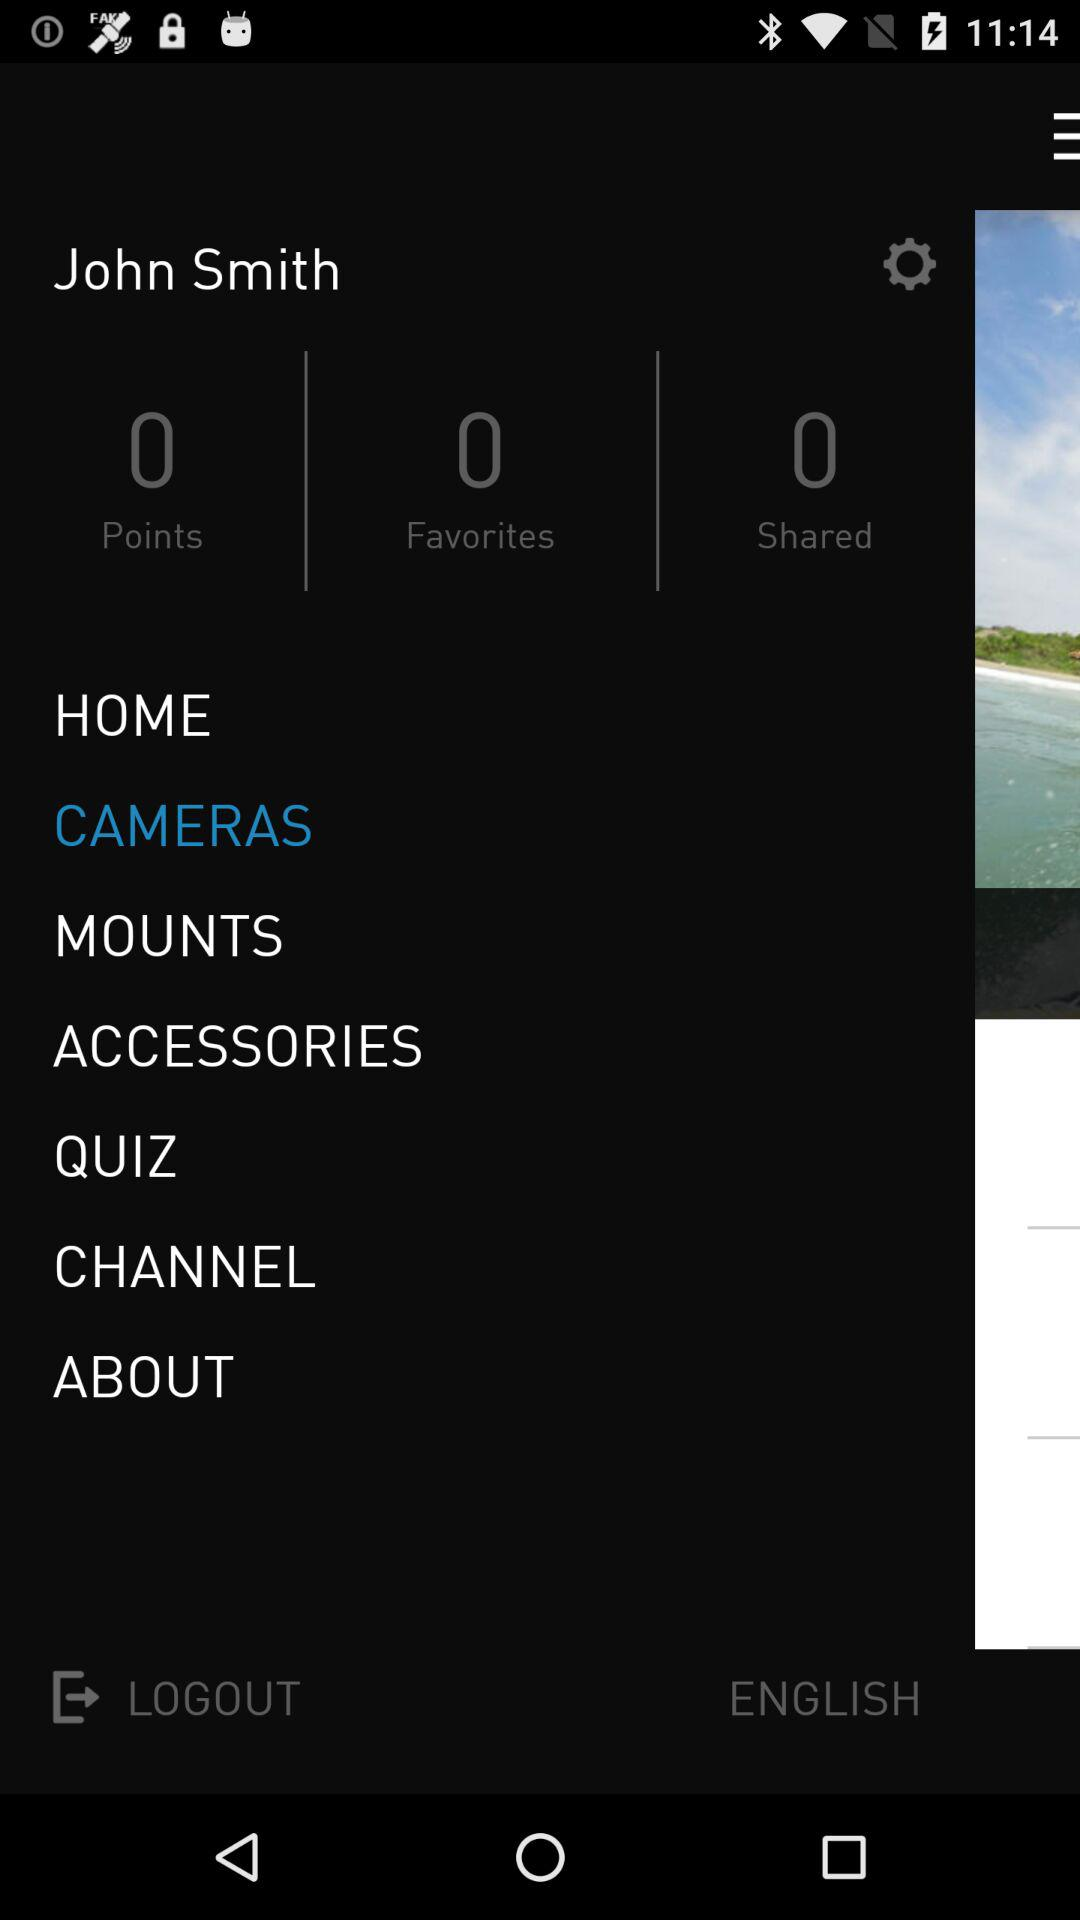What is the language? The language is English. 